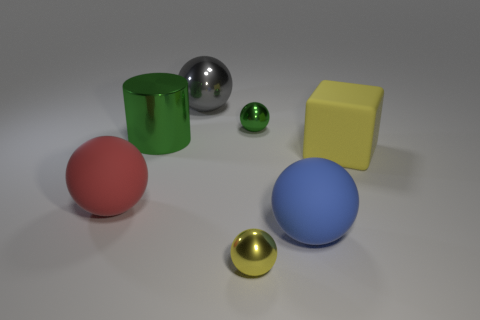Subtract 1 spheres. How many spheres are left? 4 Subtract all brown spheres. Subtract all blue cubes. How many spheres are left? 5 Add 2 tiny yellow rubber spheres. How many objects exist? 9 Subtract all cubes. How many objects are left? 6 Add 2 shiny cylinders. How many shiny cylinders exist? 3 Subtract 1 green balls. How many objects are left? 6 Subtract all blue balls. Subtract all blue matte objects. How many objects are left? 5 Add 3 metallic objects. How many metallic objects are left? 7 